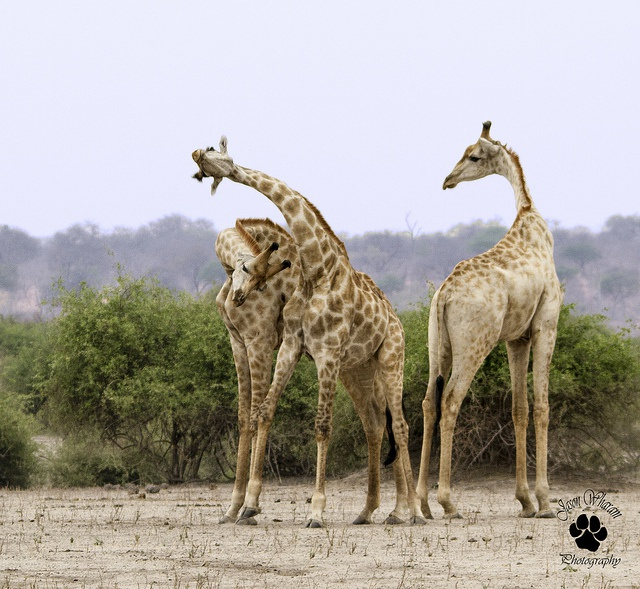Describe the objects in this image and their specific colors. I can see giraffe in lavender, tan, and olive tones, giraffe in lavender, olive, and tan tones, and giraffe in lavender, olive, tan, and gray tones in this image. 